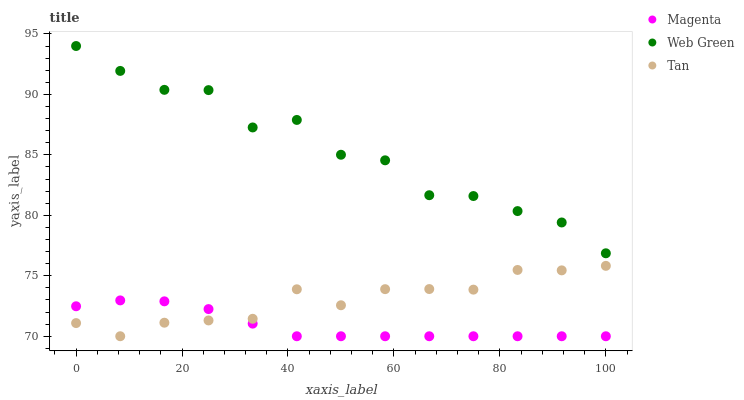Does Magenta have the minimum area under the curve?
Answer yes or no. Yes. Does Web Green have the maximum area under the curve?
Answer yes or no. Yes. Does Tan have the minimum area under the curve?
Answer yes or no. No. Does Tan have the maximum area under the curve?
Answer yes or no. No. Is Magenta the smoothest?
Answer yes or no. Yes. Is Web Green the roughest?
Answer yes or no. Yes. Is Tan the smoothest?
Answer yes or no. No. Is Tan the roughest?
Answer yes or no. No. Does Magenta have the lowest value?
Answer yes or no. Yes. Does Tan have the lowest value?
Answer yes or no. No. Does Web Green have the highest value?
Answer yes or no. Yes. Does Tan have the highest value?
Answer yes or no. No. Is Magenta less than Web Green?
Answer yes or no. Yes. Is Web Green greater than Tan?
Answer yes or no. Yes. Does Magenta intersect Tan?
Answer yes or no. Yes. Is Magenta less than Tan?
Answer yes or no. No. Is Magenta greater than Tan?
Answer yes or no. No. Does Magenta intersect Web Green?
Answer yes or no. No. 